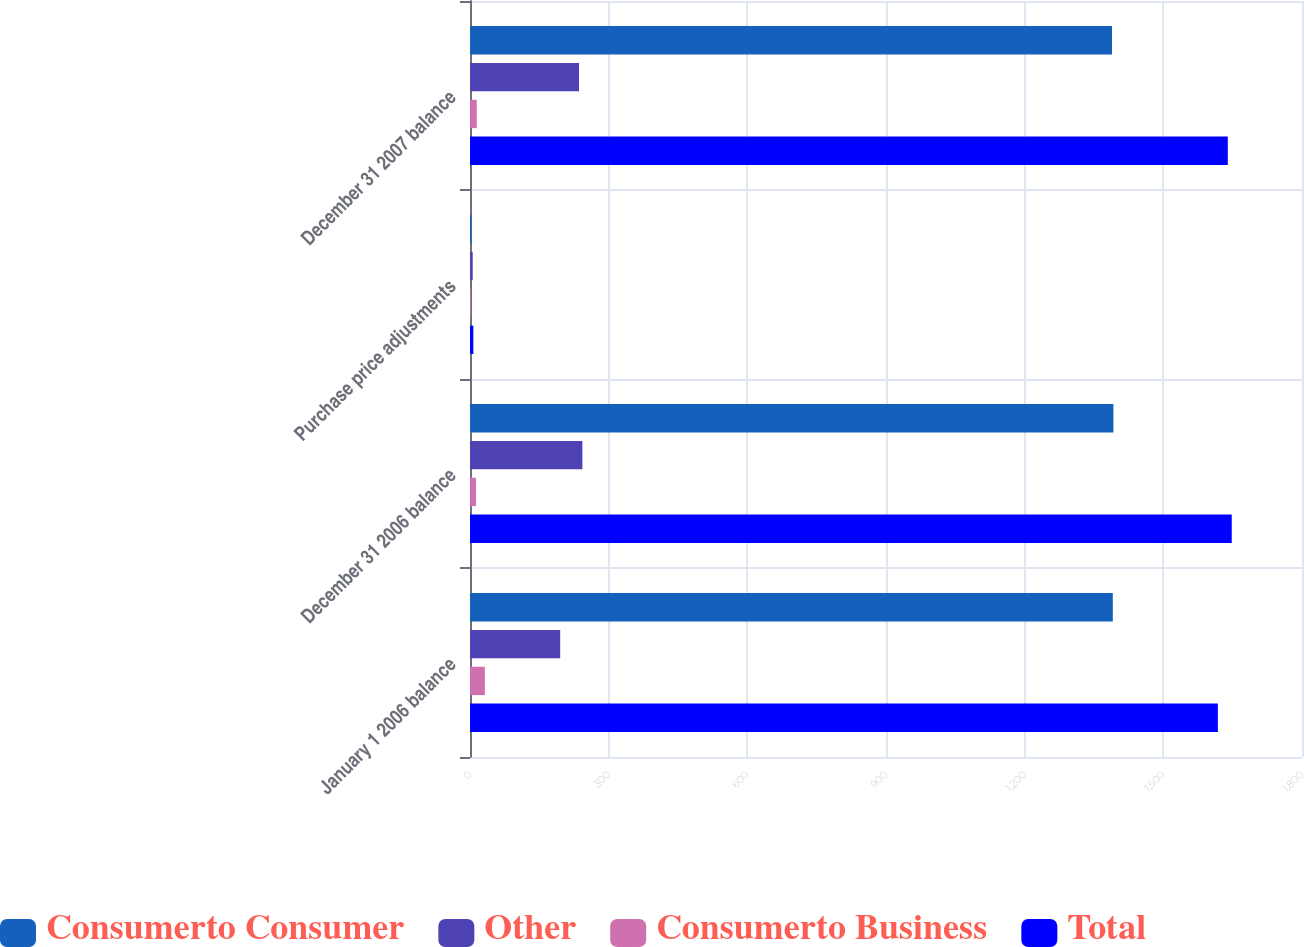<chart> <loc_0><loc_0><loc_500><loc_500><stacked_bar_chart><ecel><fcel>January 1 2006 balance<fcel>December 31 2006 balance<fcel>Purchase price adjustments<fcel>December 31 2007 balance<nl><fcel>Consumerto Consumer<fcel>1390.7<fcel>1392<fcel>3<fcel>1389<nl><fcel>Other<fcel>195.1<fcel>243.1<fcel>5.9<fcel>235.9<nl><fcel>Consumerto Business<fcel>32.2<fcel>12.9<fcel>1.7<fcel>14.6<nl><fcel>Total<fcel>1618<fcel>1648<fcel>7.2<fcel>1639.5<nl></chart> 